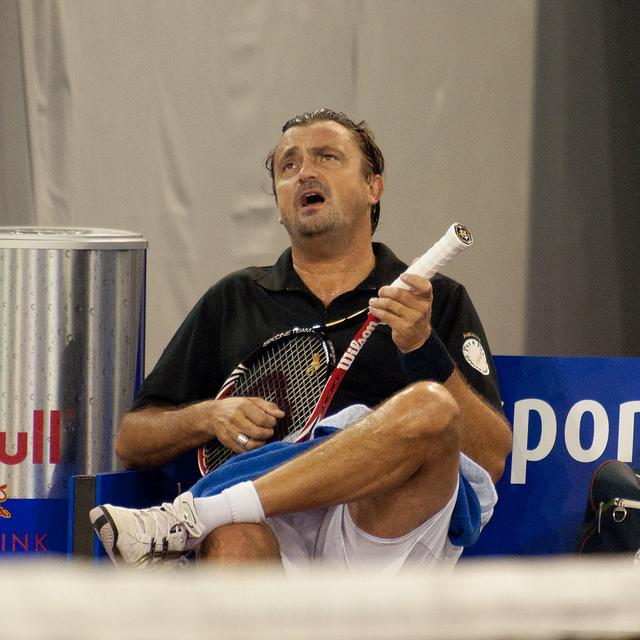He is pretending the tennis racket is what? guitar 